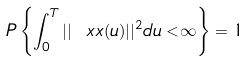Convert formula to latex. <formula><loc_0><loc_0><loc_500><loc_500>P \left \{ \int _ { 0 } ^ { T } | | \ x x ( u ) | | ^ { 2 } d u < \infty \right \} = 1</formula> 